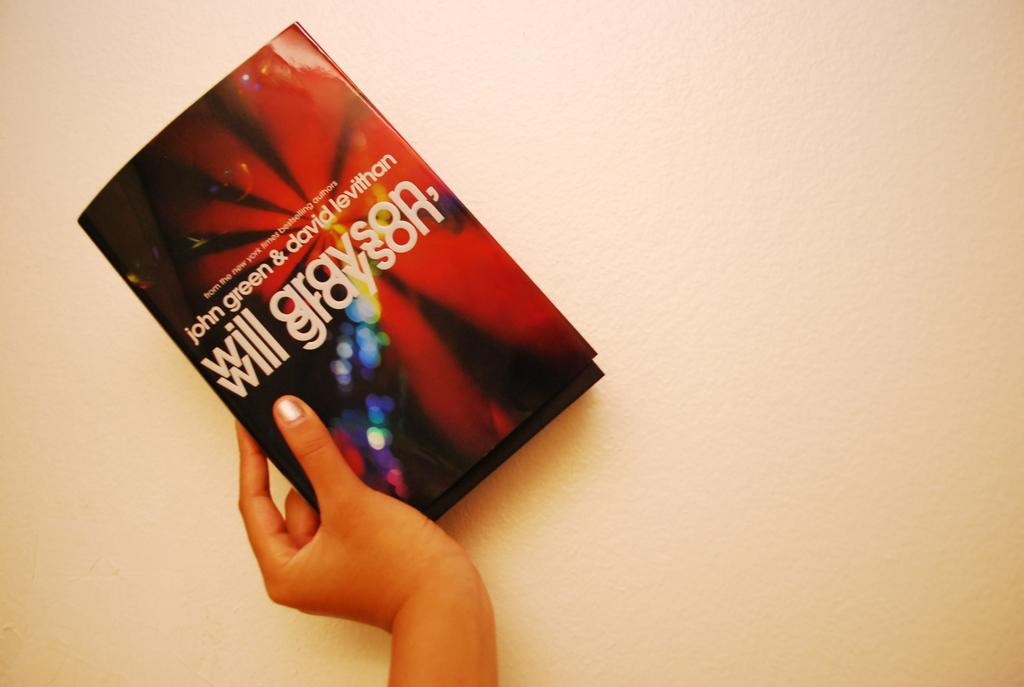<image>
Write a terse but informative summary of the picture. Person holding a booklet that says "Will Grayson" on it. 